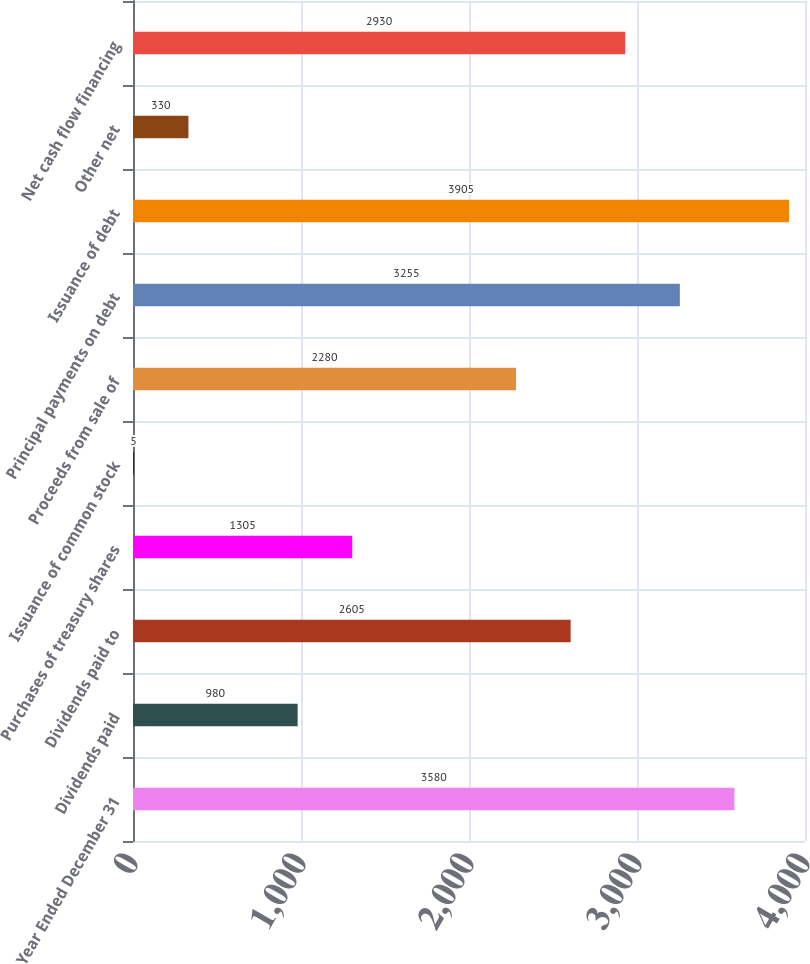Convert chart. <chart><loc_0><loc_0><loc_500><loc_500><bar_chart><fcel>Year Ended December 31<fcel>Dividends paid<fcel>Dividends paid to<fcel>Purchases of treasury shares<fcel>Issuance of common stock<fcel>Proceeds from sale of<fcel>Principal payments on debt<fcel>Issuance of debt<fcel>Other net<fcel>Net cash flow financing<nl><fcel>3580<fcel>980<fcel>2605<fcel>1305<fcel>5<fcel>2280<fcel>3255<fcel>3905<fcel>330<fcel>2930<nl></chart> 